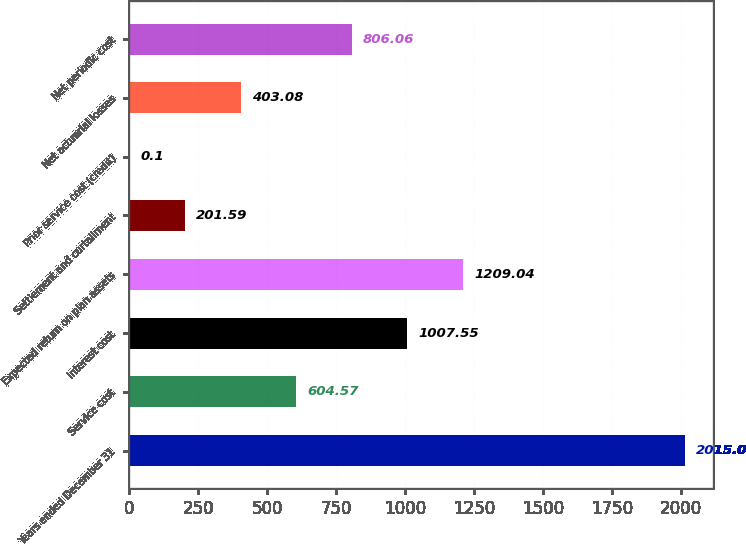<chart> <loc_0><loc_0><loc_500><loc_500><bar_chart><fcel>Years ended December 31<fcel>Service cost<fcel>Interest cost<fcel>Expected return on plan assets<fcel>Settlement and curtailment<fcel>Prior service cost (credit)<fcel>Net actuarial losses<fcel>Net periodic cost<nl><fcel>2015<fcel>604.57<fcel>1007.55<fcel>1209.04<fcel>201.59<fcel>0.1<fcel>403.08<fcel>806.06<nl></chart> 